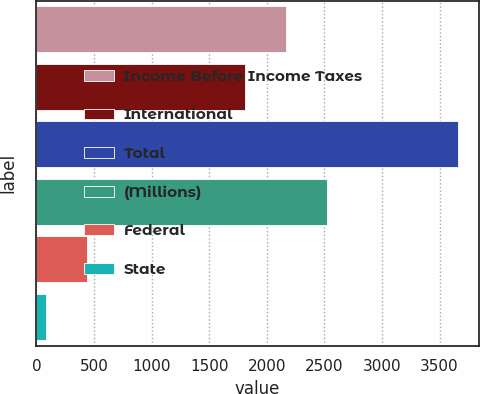<chart> <loc_0><loc_0><loc_500><loc_500><bar_chart><fcel>Income Before Income Taxes<fcel>International<fcel>Total<fcel>(Millions)<fcel>Federal<fcel>State<nl><fcel>2166.6<fcel>1809<fcel>3657<fcel>2524.2<fcel>438.6<fcel>81<nl></chart> 